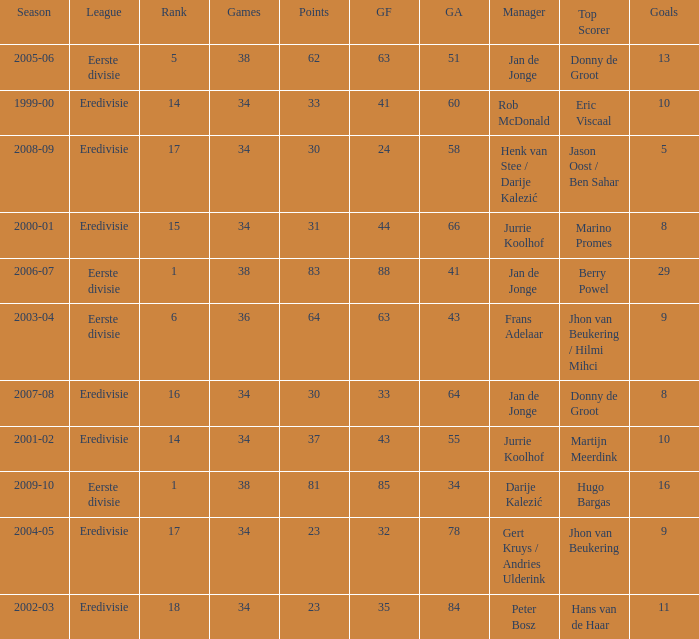Who is the manager whose rank is 16? Jan de Jonge. 